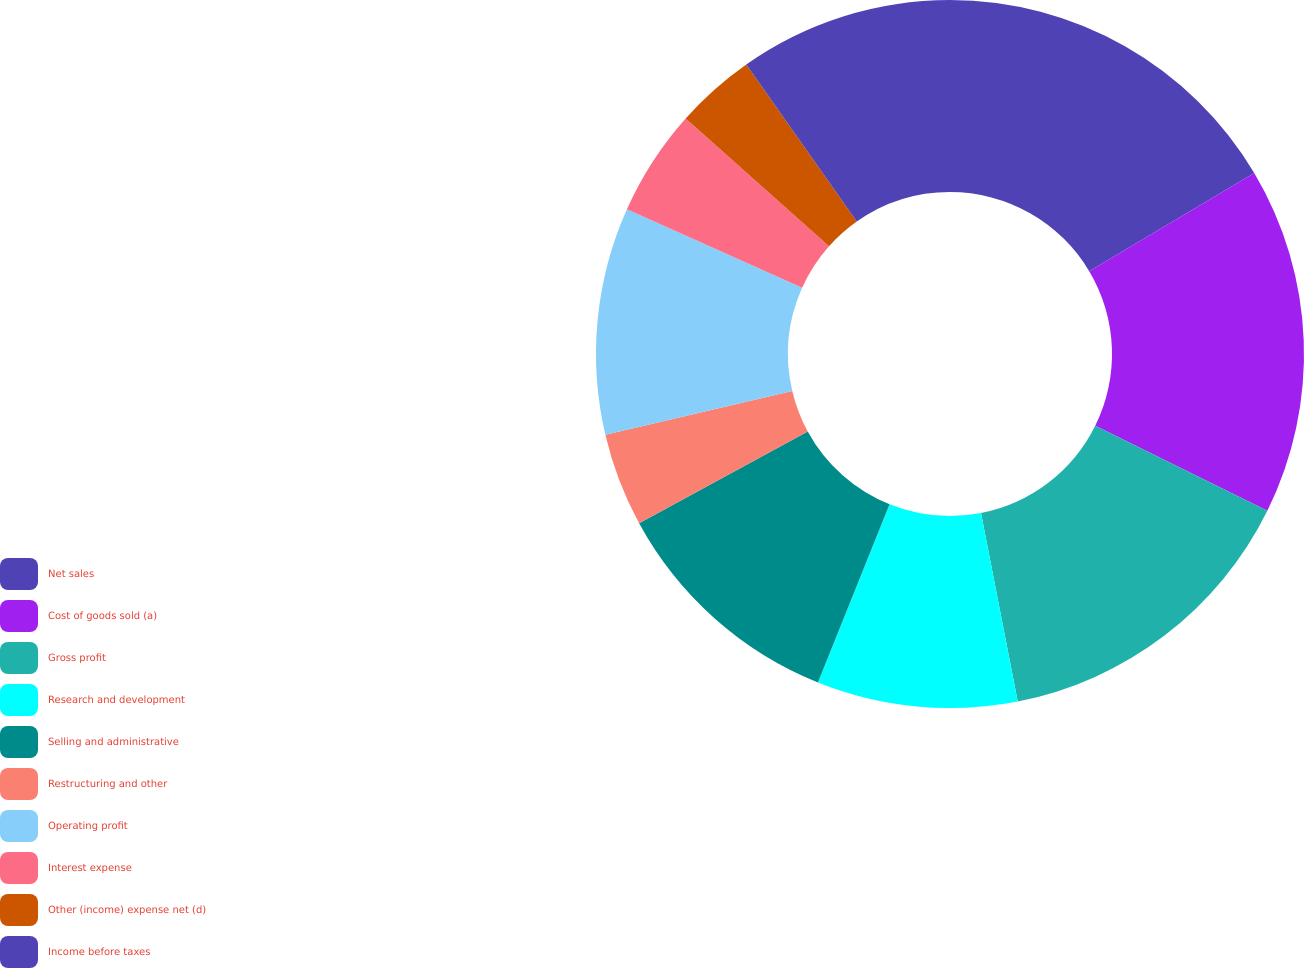Convert chart to OTSL. <chart><loc_0><loc_0><loc_500><loc_500><pie_chart><fcel>Net sales<fcel>Cost of goods sold (a)<fcel>Gross profit<fcel>Research and development<fcel>Selling and administrative<fcel>Restructuring and other<fcel>Operating profit<fcel>Interest expense<fcel>Other (income) expense net (d)<fcel>Income before taxes<nl><fcel>16.46%<fcel>15.85%<fcel>14.63%<fcel>9.15%<fcel>10.98%<fcel>4.27%<fcel>10.37%<fcel>4.88%<fcel>3.66%<fcel>9.76%<nl></chart> 